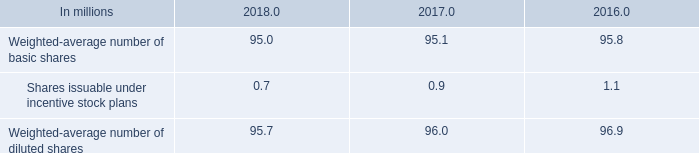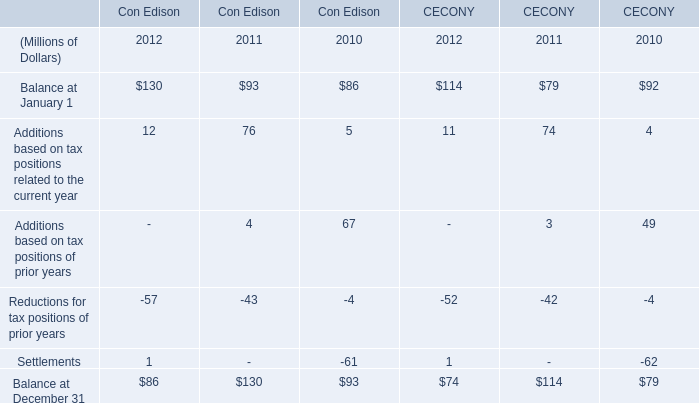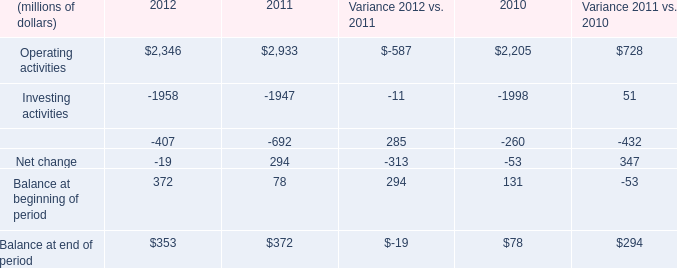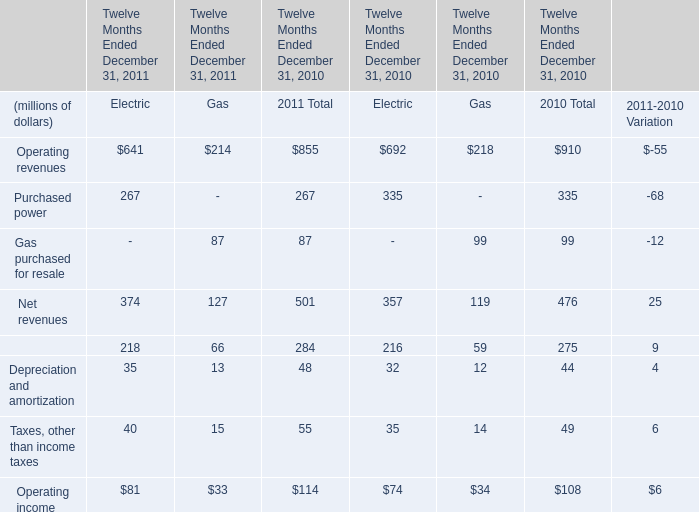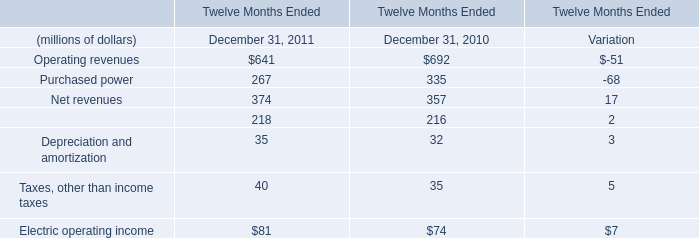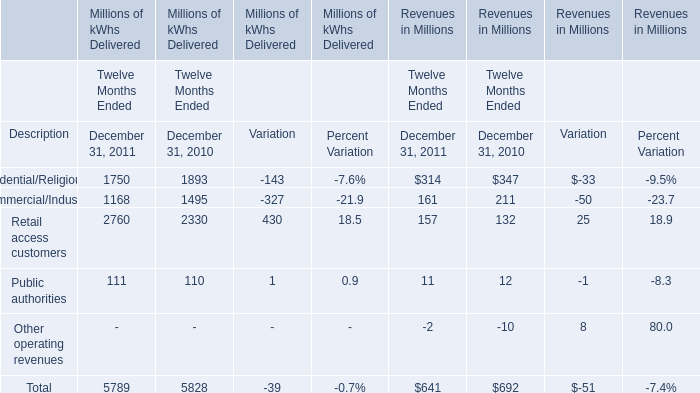Which year is Operating income of Electric the highest? 
Answer: 2011. 